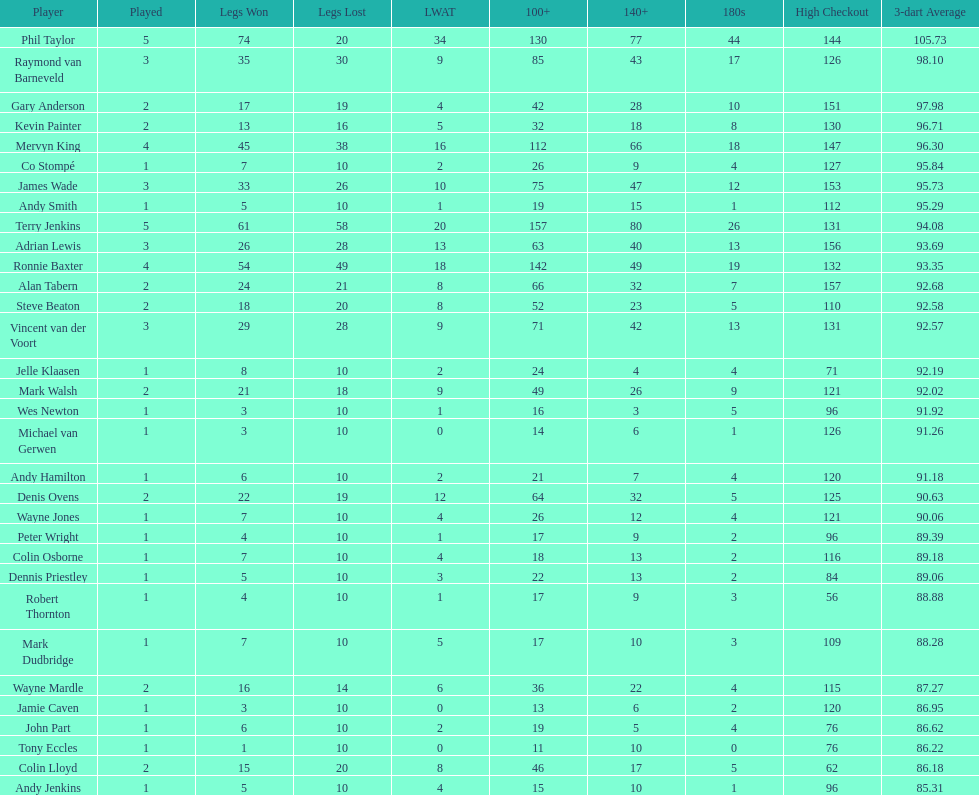Which player experienced the least defeat? Co Stompé, Andy Smith, Jelle Klaasen, Wes Newton, Michael van Gerwen, Andy Hamilton, Wayne Jones, Peter Wright, Colin Osborne, Dennis Priestley, Robert Thornton, Mark Dudbridge, Jamie Caven, John Part, Tony Eccles, Andy Jenkins. 